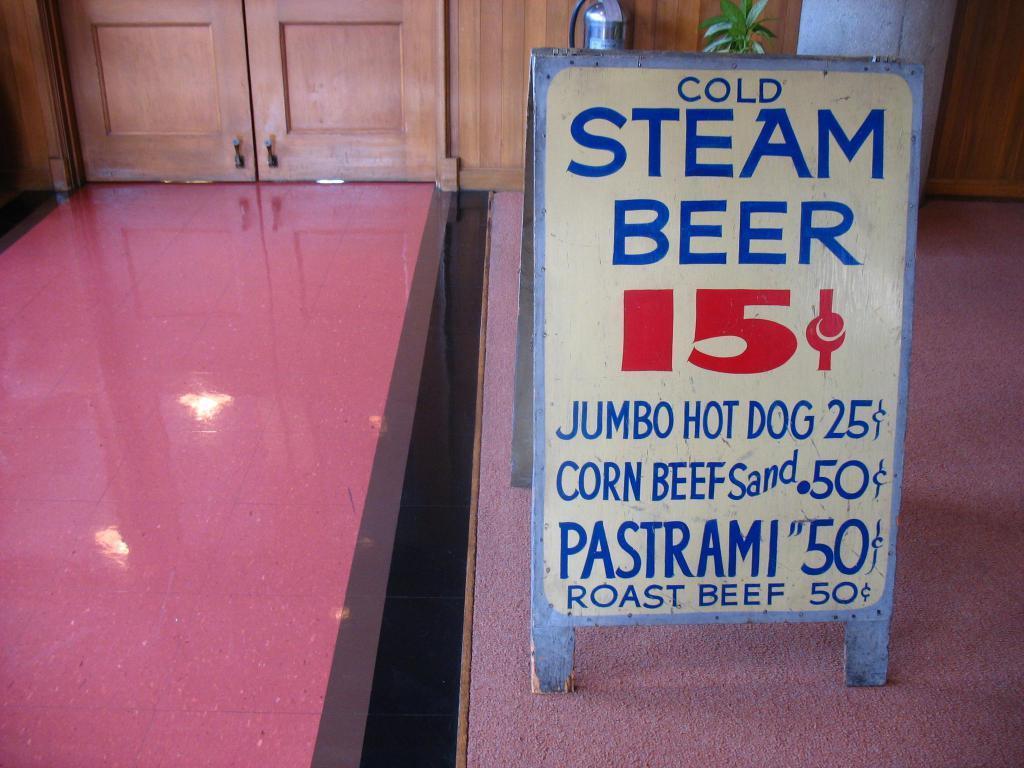How would you summarize this image in a sentence or two? On the right side of this image there is a board placed on a wooden object. On the board, I can see some text. On the left side I can see the light reflections on the floor. At the top there are two doors and a plant and also there is a metal object. 